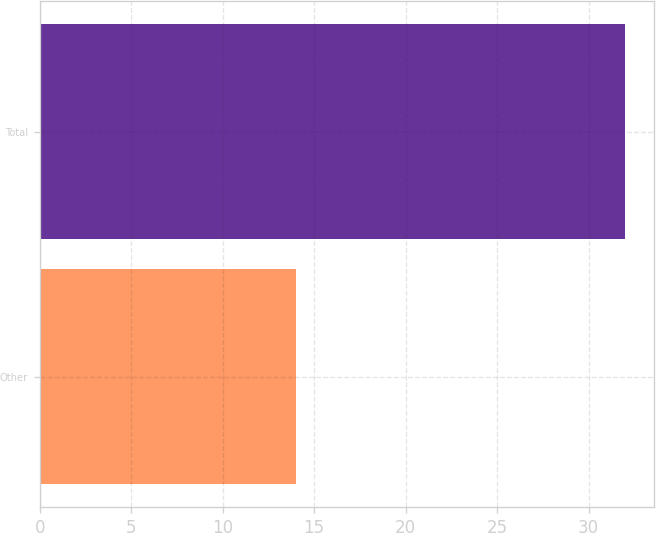Convert chart. <chart><loc_0><loc_0><loc_500><loc_500><bar_chart><fcel>Other<fcel>Total<nl><fcel>14<fcel>32<nl></chart> 